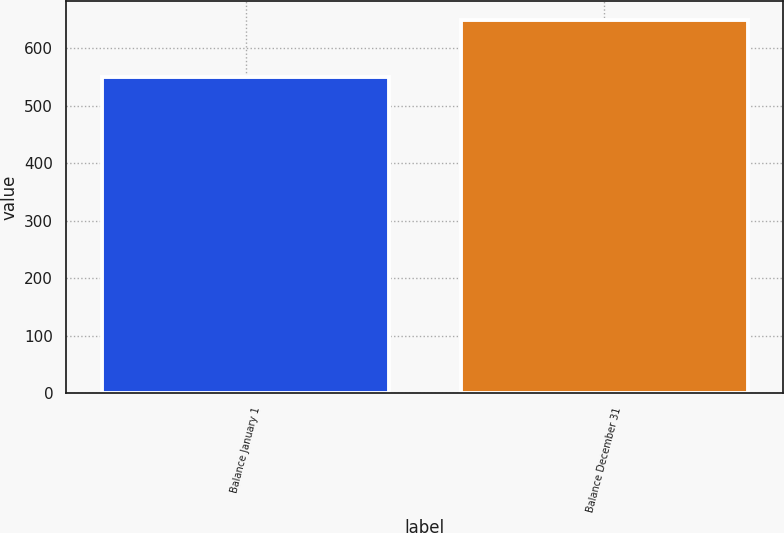<chart> <loc_0><loc_0><loc_500><loc_500><bar_chart><fcel>Balance January 1<fcel>Balance December 31<nl><fcel>550<fcel>650<nl></chart> 